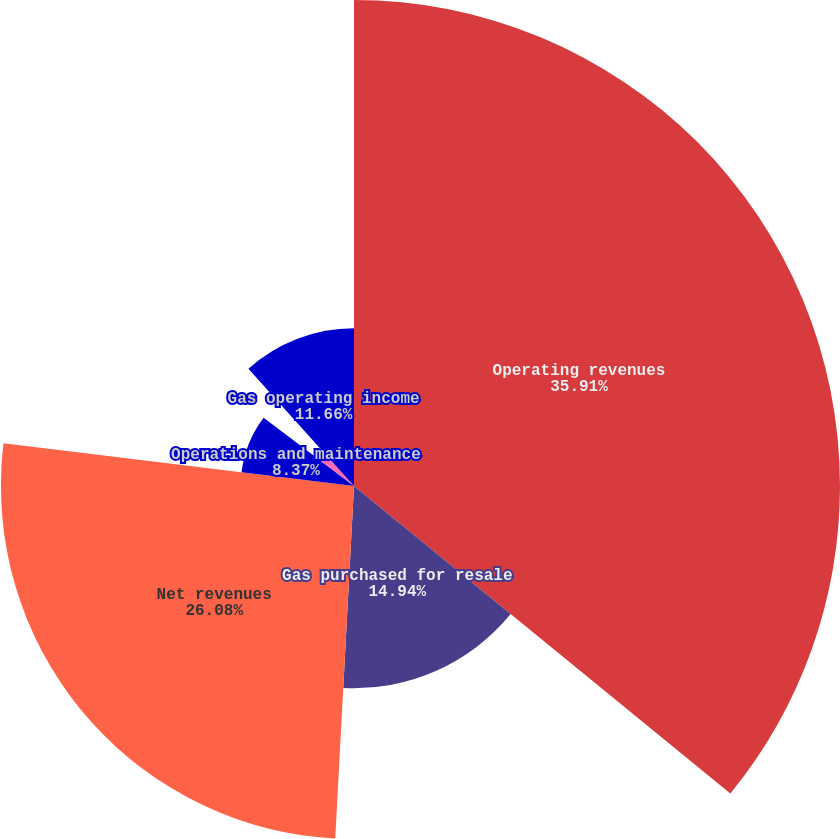Convert chart to OTSL. <chart><loc_0><loc_0><loc_500><loc_500><pie_chart><fcel>Operating revenues<fcel>Gas purchased for resale<fcel>Net revenues<fcel>Operations and maintenance<fcel>Depreciation and amortization<fcel>Gas operating income<nl><fcel>35.9%<fcel>14.94%<fcel>26.08%<fcel>8.37%<fcel>3.04%<fcel>11.66%<nl></chart> 